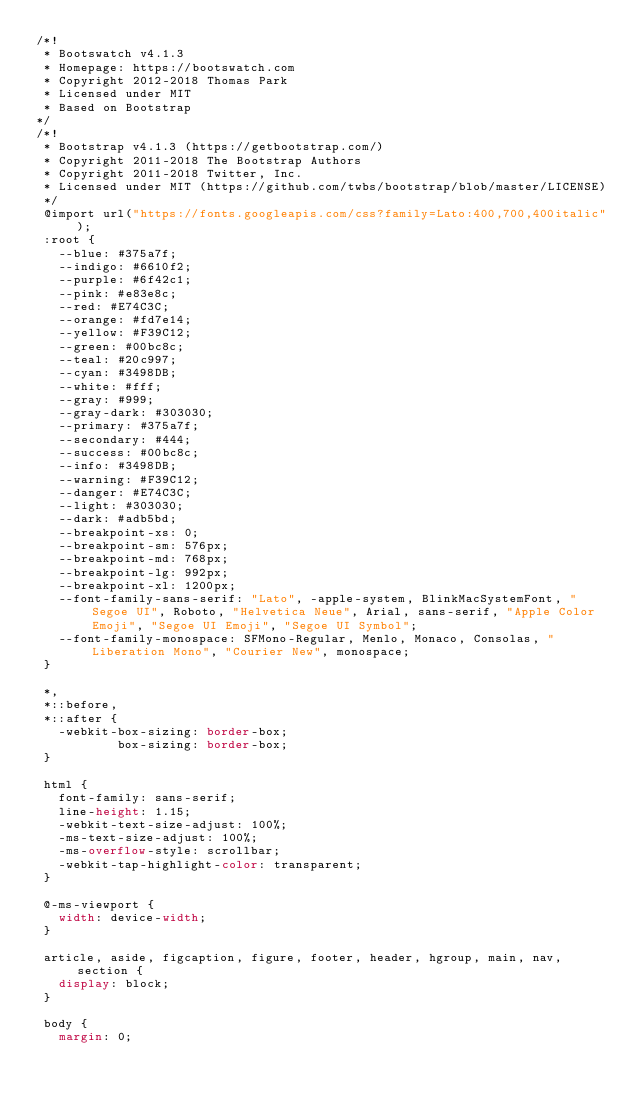<code> <loc_0><loc_0><loc_500><loc_500><_CSS_>/*!
 * Bootswatch v4.1.3
 * Homepage: https://bootswatch.com
 * Copyright 2012-2018 Thomas Park
 * Licensed under MIT
 * Based on Bootstrap
*/
/*!
 * Bootstrap v4.1.3 (https://getbootstrap.com/)
 * Copyright 2011-2018 The Bootstrap Authors
 * Copyright 2011-2018 Twitter, Inc.
 * Licensed under MIT (https://github.com/twbs/bootstrap/blob/master/LICENSE)
 */
 @import url("https://fonts.googleapis.com/css?family=Lato:400,700,400italic");
 :root {
   --blue: #375a7f;
   --indigo: #6610f2;
   --purple: #6f42c1;
   --pink: #e83e8c;
   --red: #E74C3C;
   --orange: #fd7e14;
   --yellow: #F39C12;
   --green: #00bc8c;
   --teal: #20c997;
   --cyan: #3498DB;
   --white: #fff;
   --gray: #999;
   --gray-dark: #303030;
   --primary: #375a7f;
   --secondary: #444;
   --success: #00bc8c;
   --info: #3498DB;
   --warning: #F39C12;
   --danger: #E74C3C;
   --light: #303030;
   --dark: #adb5bd;
   --breakpoint-xs: 0;
   --breakpoint-sm: 576px;
   --breakpoint-md: 768px;
   --breakpoint-lg: 992px;
   --breakpoint-xl: 1200px;
   --font-family-sans-serif: "Lato", -apple-system, BlinkMacSystemFont, "Segoe UI", Roboto, "Helvetica Neue", Arial, sans-serif, "Apple Color Emoji", "Segoe UI Emoji", "Segoe UI Symbol";
   --font-family-monospace: SFMono-Regular, Menlo, Monaco, Consolas, "Liberation Mono", "Courier New", monospace;
 }
 
 *,
 *::before,
 *::after {
   -webkit-box-sizing: border-box;
           box-sizing: border-box;
 }
 
 html {
   font-family: sans-serif;
   line-height: 1.15;
   -webkit-text-size-adjust: 100%;
   -ms-text-size-adjust: 100%;
   -ms-overflow-style: scrollbar;
   -webkit-tap-highlight-color: transparent;
 }
 
 @-ms-viewport {
   width: device-width;
 }
 
 article, aside, figcaption, figure, footer, header, hgroup, main, nav, section {
   display: block;
 }
 
 body {
   margin: 0;</code> 